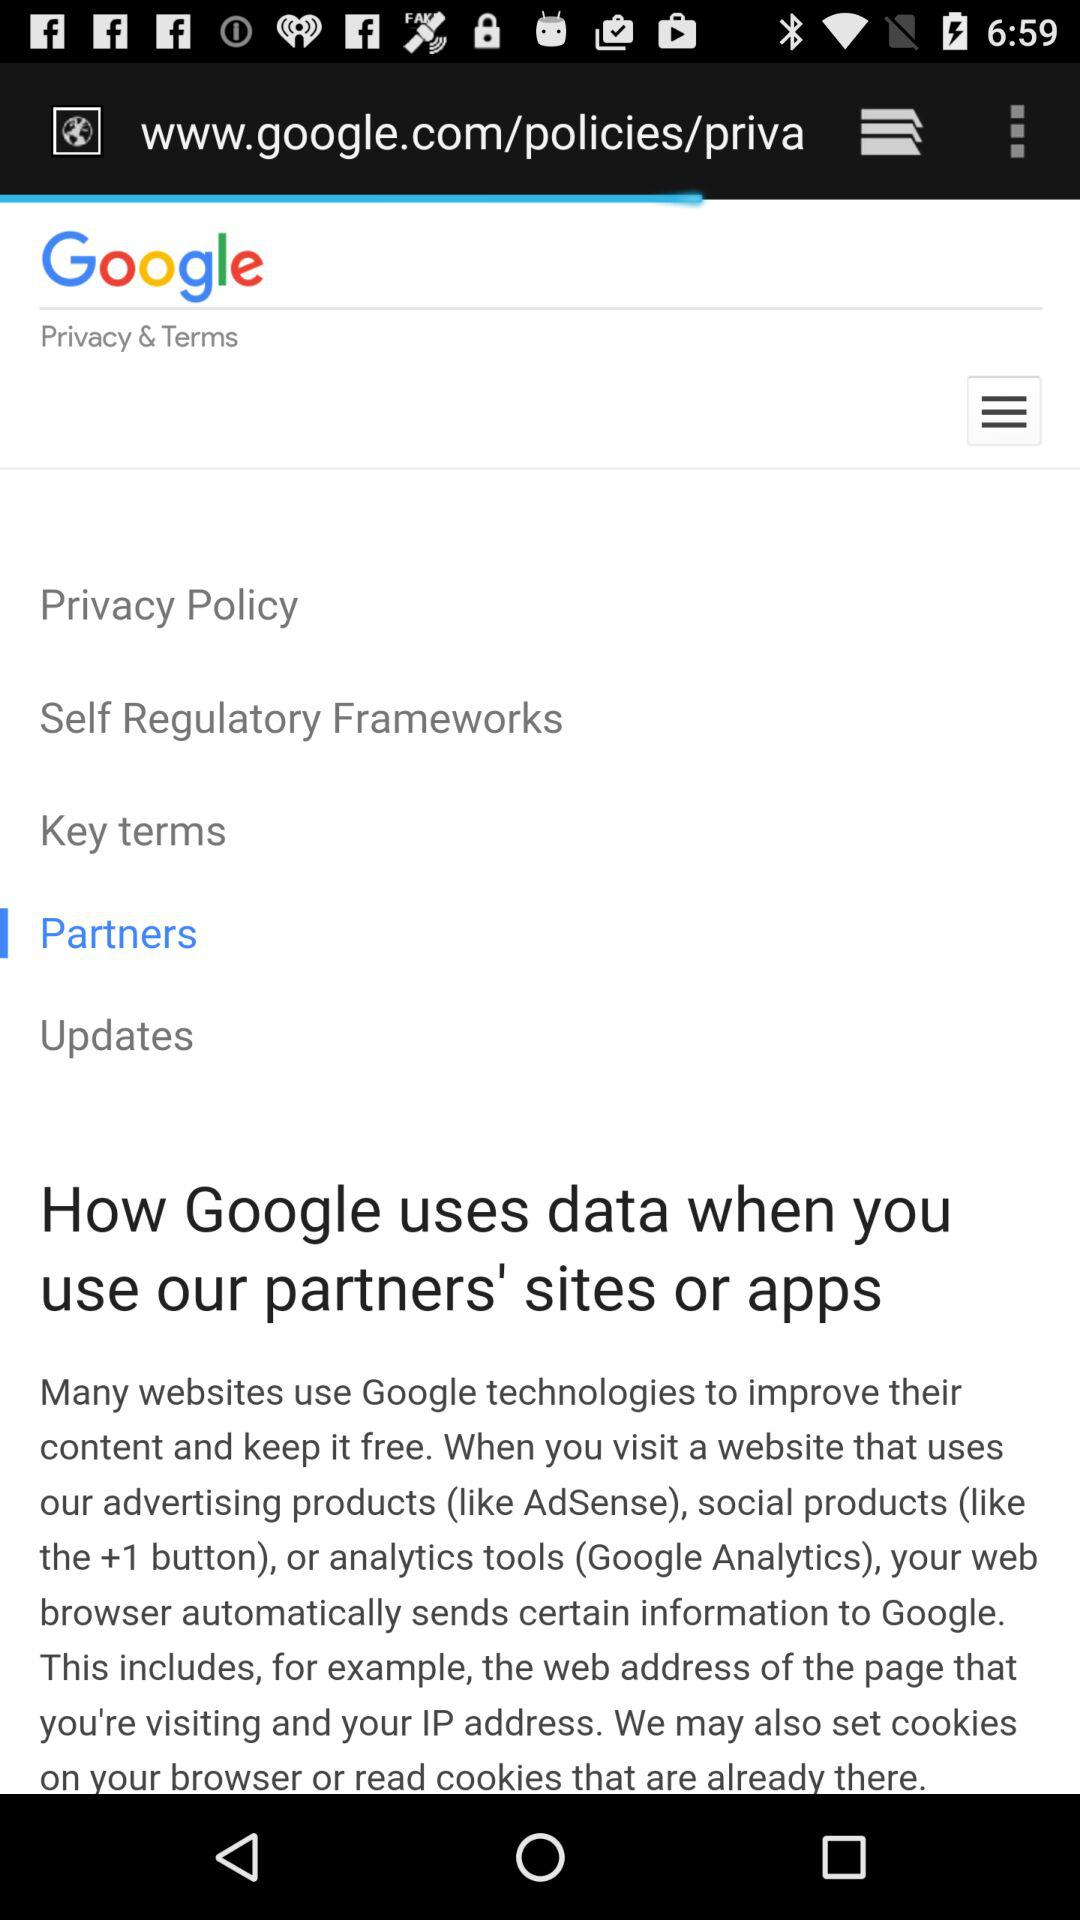Which option is selected? The selected option is "Partners". 